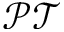<formula> <loc_0><loc_0><loc_500><loc_500>\mathcal { P T }</formula> 